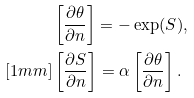Convert formula to latex. <formula><loc_0><loc_0><loc_500><loc_500>& \left [ \frac { \partial \theta } { \partial n } \right ] = - \exp ( S ) , \\ [ 1 m m ] & \left [ \frac { \partial S } { \partial n } \right ] = \alpha \left [ \frac { \partial \theta } { \partial n } \right ] .</formula> 